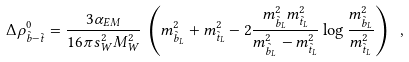Convert formula to latex. <formula><loc_0><loc_0><loc_500><loc_500>\Delta \rho _ { \tilde { b } - \tilde { t } } ^ { 0 } = \frac { 3 \alpha _ { E M } } { 1 6 \pi s _ { W } ^ { 2 } M _ { W } ^ { 2 } } \, \left ( m _ { \tilde { b } _ { L } } ^ { 2 } + m _ { \tilde { t } _ { L } } ^ { 2 } - 2 \frac { m _ { \tilde { b } _ { L } } ^ { 2 } m _ { \tilde { t } _ { L } } ^ { 2 } } { m _ { \tilde { b } _ { L } } ^ { 2 } - m _ { \tilde { t } _ { L } } ^ { 2 } } \log \frac { m _ { \tilde { b } _ { L } } ^ { 2 } } { m _ { \tilde { t } _ { L } } ^ { 2 } } \right ) \ ,</formula> 